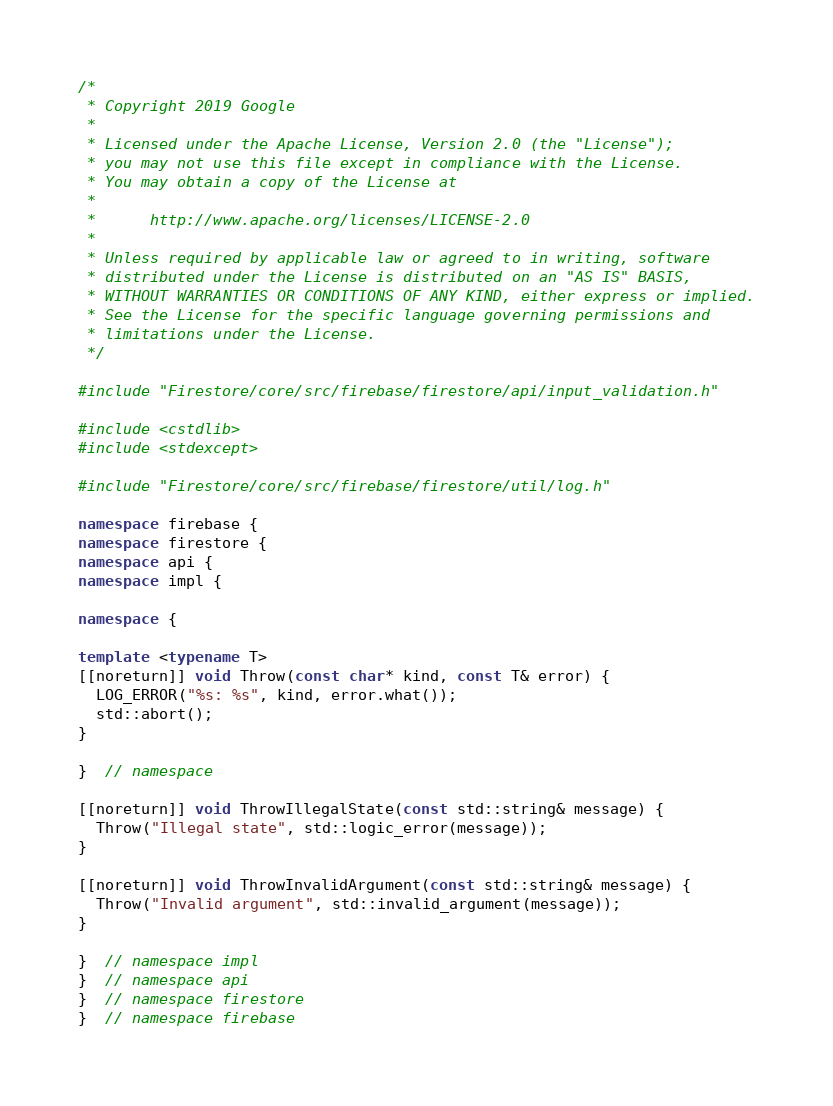Convert code to text. <code><loc_0><loc_0><loc_500><loc_500><_C++_>/*
 * Copyright 2019 Google
 *
 * Licensed under the Apache License, Version 2.0 (the "License");
 * you may not use this file except in compliance with the License.
 * You may obtain a copy of the License at
 *
 *      http://www.apache.org/licenses/LICENSE-2.0
 *
 * Unless required by applicable law or agreed to in writing, software
 * distributed under the License is distributed on an "AS IS" BASIS,
 * WITHOUT WARRANTIES OR CONDITIONS OF ANY KIND, either express or implied.
 * See the License for the specific language governing permissions and
 * limitations under the License.
 */

#include "Firestore/core/src/firebase/firestore/api/input_validation.h"

#include <cstdlib>
#include <stdexcept>

#include "Firestore/core/src/firebase/firestore/util/log.h"

namespace firebase {
namespace firestore {
namespace api {
namespace impl {

namespace {

template <typename T>
[[noreturn]] void Throw(const char* kind, const T& error) {
  LOG_ERROR("%s: %s", kind, error.what());
  std::abort();
}

}  // namespace

[[noreturn]] void ThrowIllegalState(const std::string& message) {
  Throw("Illegal state", std::logic_error(message));
}

[[noreturn]] void ThrowInvalidArgument(const std::string& message) {
  Throw("Invalid argument", std::invalid_argument(message));
}

}  // namespace impl
}  // namespace api
}  // namespace firestore
}  // namespace firebase
</code> 